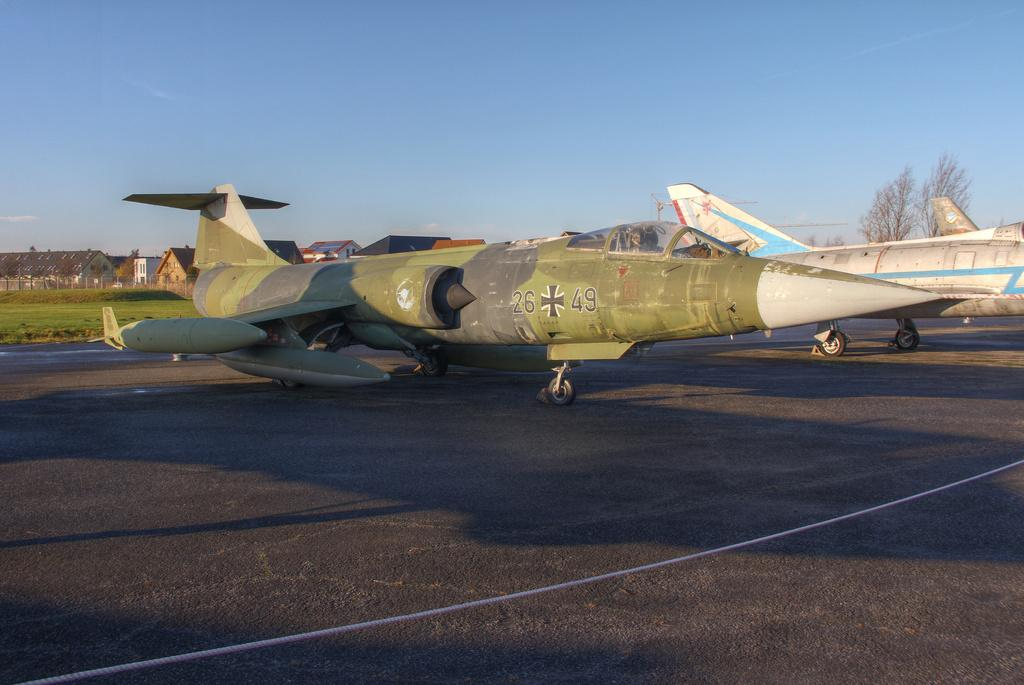<image>
Render a clear and concise summary of the photo. Air craft carrier with call numbers 26 49 sitting on a tarmac. 